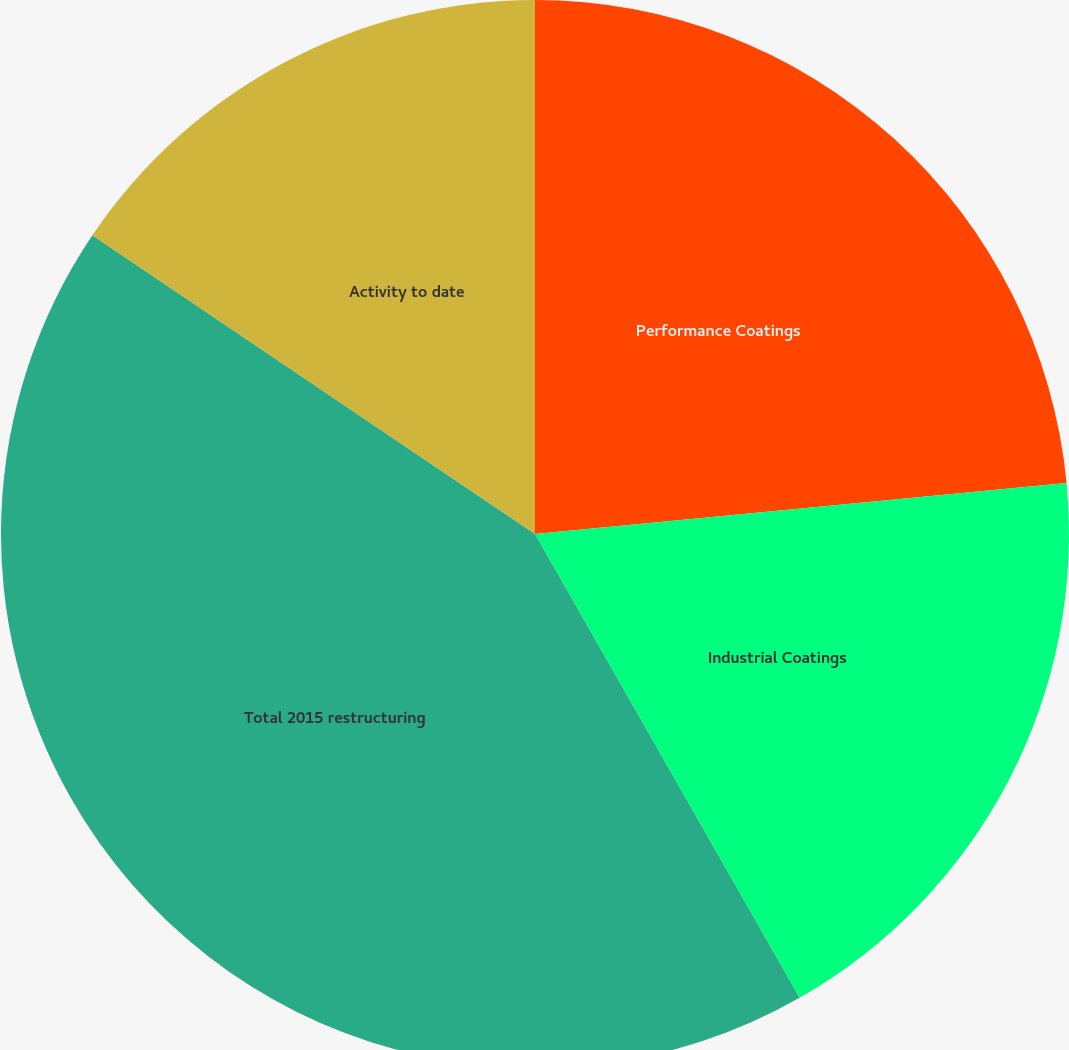<chart> <loc_0><loc_0><loc_500><loc_500><pie_chart><fcel>Performance Coatings<fcel>Industrial Coatings<fcel>Total 2015 restructuring<fcel>Activity to date<nl><fcel>23.48%<fcel>18.27%<fcel>42.7%<fcel>15.55%<nl></chart> 